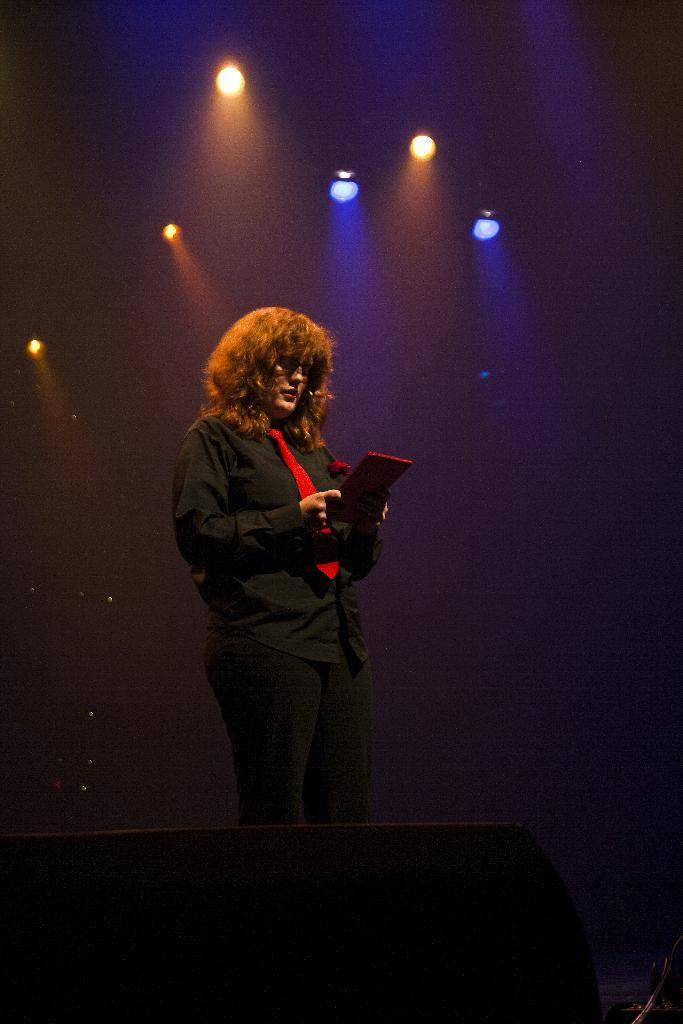Who or what is present in the image? There is a person in the image. What is the person wearing? The person is wearing a black dress and a red tie. What colors can be seen in the background of the image? There are yellow and blue lights in the background of the image. What shape is the balloon in the image? There is no balloon present in the image. What type of cast is visible on the person's arm in the image? There is no cast visible on the person's arm in the image. 